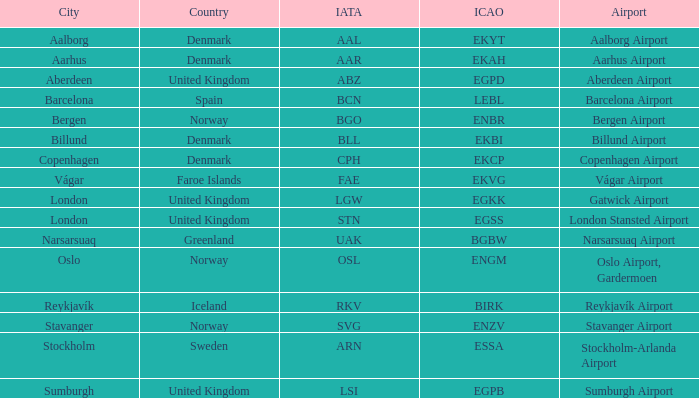What is the ICAO for Denmark, and the IATA is bll? EKBI. 